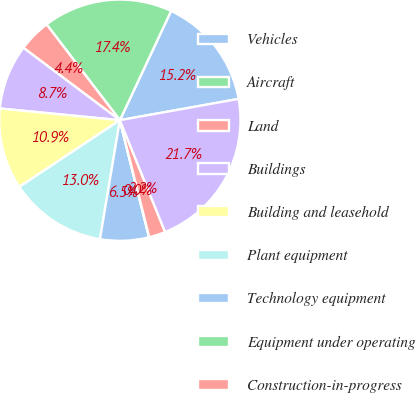Convert chart to OTSL. <chart><loc_0><loc_0><loc_500><loc_500><pie_chart><fcel>Vehicles<fcel>Aircraft<fcel>Land<fcel>Buildings<fcel>Building and leasehold<fcel>Plant equipment<fcel>Technology equipment<fcel>Equipment under operating<fcel>Construction-in-progress<fcel>Less Accumulated depreciation<nl><fcel>15.2%<fcel>17.37%<fcel>4.36%<fcel>8.7%<fcel>10.87%<fcel>13.04%<fcel>6.53%<fcel>0.03%<fcel>2.2%<fcel>21.71%<nl></chart> 